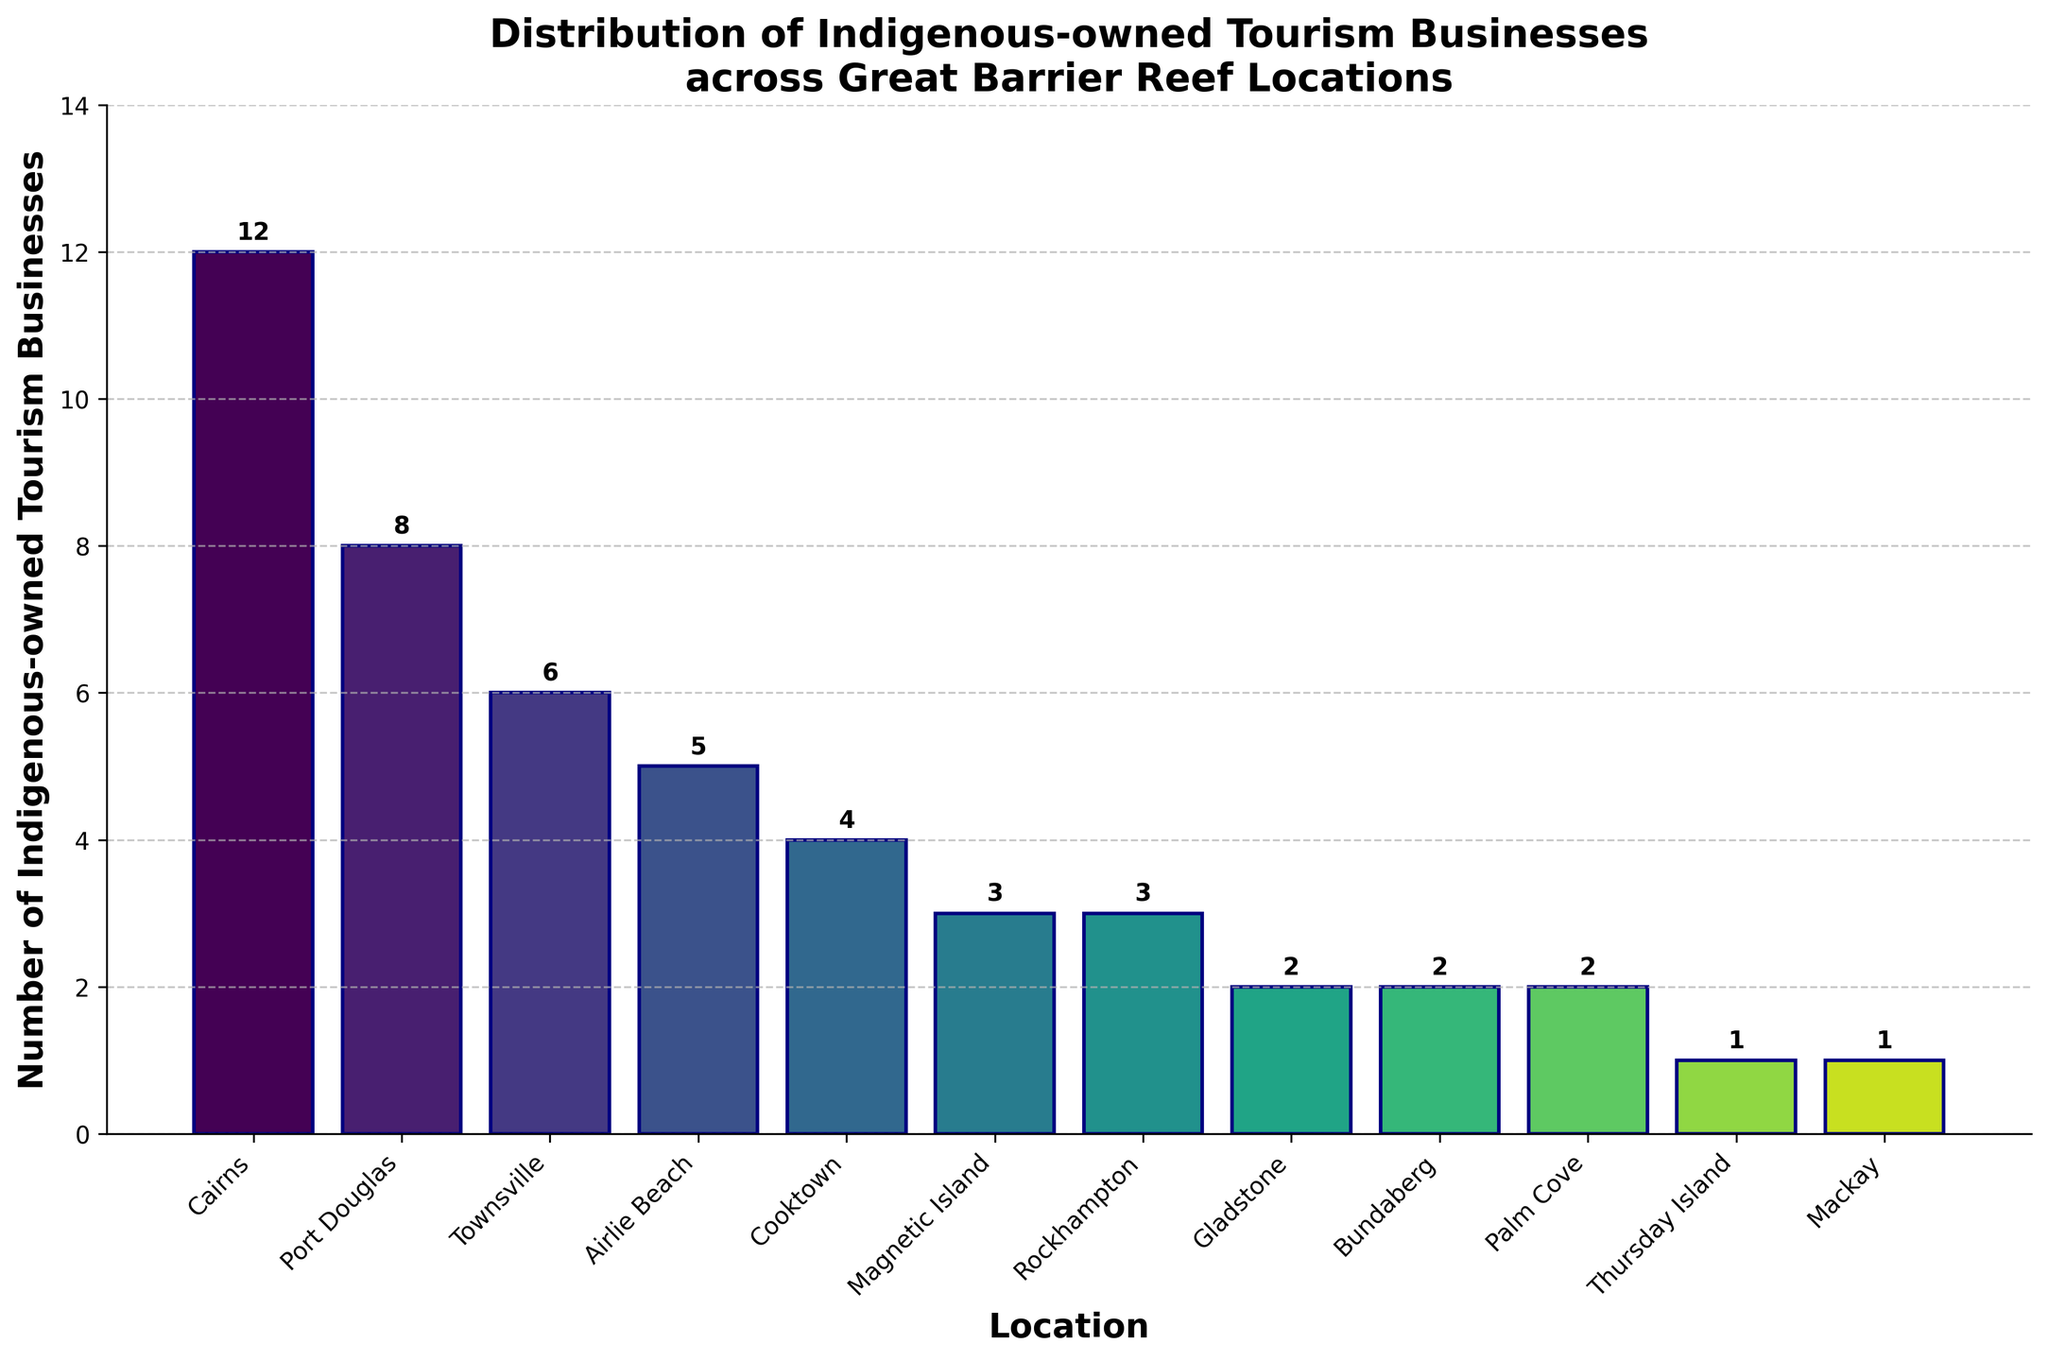What's the highest number of indigenous-owned tourism businesses in a location? Look at the figure to find the tallest bar, which represents Cairns with 12 businesses
Answer: 12 Which two locations have the same number of indigenous-owned tourism businesses? Observe the bars with equal heights in the figure. Both Rockhampton and Magnetic Island have 3 businesses each, and Bundaberg and Palm Cove have 2 businesses each.
Answer: Rockhampton and Magnetic Island, Bundaberg and Palm Cove What's the total number of indigenous-owned tourism businesses in Cairns, Port Douglas, and Townsville combined? Sum the values corresponding to these locations: Cairns (12) + Port Douglas (8) + Townsville (6) = 26
Answer: 26 Which location has the fewest indigenous-owned tourism businesses? Find the shortest bar in the figure, which represents Thursday Island and Mackay with 1 business each
Answer: Thursday Island and Mackay How many more indigenous-owned tourism businesses does Cairns have compared to Rockhampton? Subtract the number of businesses in Rockhampton from those in Cairns: 12 - 3 = 9
Answer: 9 On average, how many indigenous-owned tourism businesses are there across all locations? Sum all businesses: 12 + 8 + 6 + 5 + 4 + 3 + 3 + 2 + 2 + 2 + 1 + 1 = 49. Divide by the number of locations: 49/12 ≈ 4.08
Answer: 4.08 Rank the top three locations by the number of indigenous-owned tourism businesses? Order the locations by the height of the bars, from highest to lowest: Cairns (12), Port Douglas (8), Townsville (6)
Answer: Cairns, Port Douglas, Townsville Which locations have fewer than 5 indigenous-owned tourism businesses? Identify bars lower than the 5 mark: Cooktown (4), Magnetic Island (3), Rockhampton (3), Gladstone (2), Bundaberg (2), Palm Cove (2), Thursday Island (1), Mackay (1)
Answer: Cooktown, Magnetic Island, Rockhampton, Gladstone, Bundaberg, Palm Cove, Thursday Island, Mackay What is the difference in the number of indigenous-owned tourism businesses between Airlie Beach and Cooktown? Subtract the number of businesses in Cooktown from those in Airlie Beach: 5 - 4 = 1
Answer: 1 